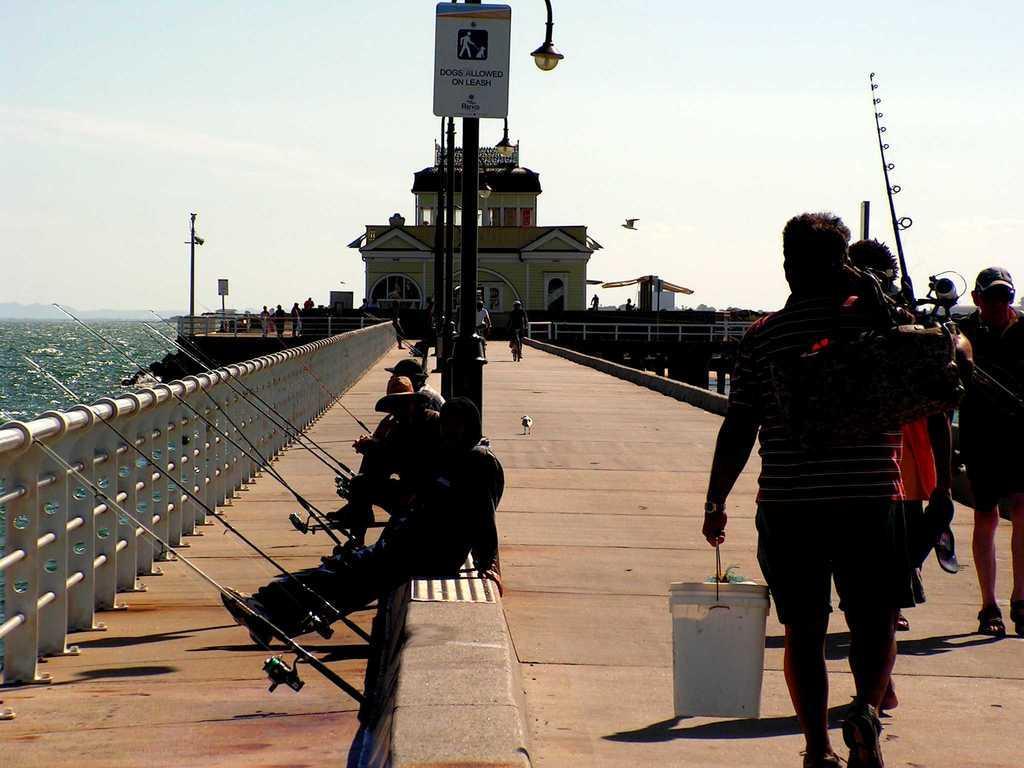How would you summarize this image in a sentence or two? In the foreground of this image, there is path and few persons sitting a side, holding fishing rod in their hands. On right, there are persons walking on the path and there are few poles, lights, building and a bird flying in the air. On left, there is water and the sky. 